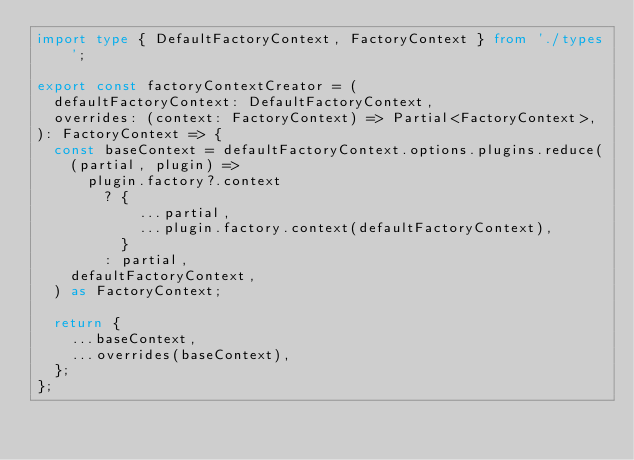Convert code to text. <code><loc_0><loc_0><loc_500><loc_500><_TypeScript_>import type { DefaultFactoryContext, FactoryContext } from './types';

export const factoryContextCreator = (
  defaultFactoryContext: DefaultFactoryContext,
  overrides: (context: FactoryContext) => Partial<FactoryContext>,
): FactoryContext => {
  const baseContext = defaultFactoryContext.options.plugins.reduce(
    (partial, plugin) =>
      plugin.factory?.context
        ? {
            ...partial,
            ...plugin.factory.context(defaultFactoryContext),
          }
        : partial,
    defaultFactoryContext,
  ) as FactoryContext;

  return {
    ...baseContext,
    ...overrides(baseContext),
  };
};
</code> 